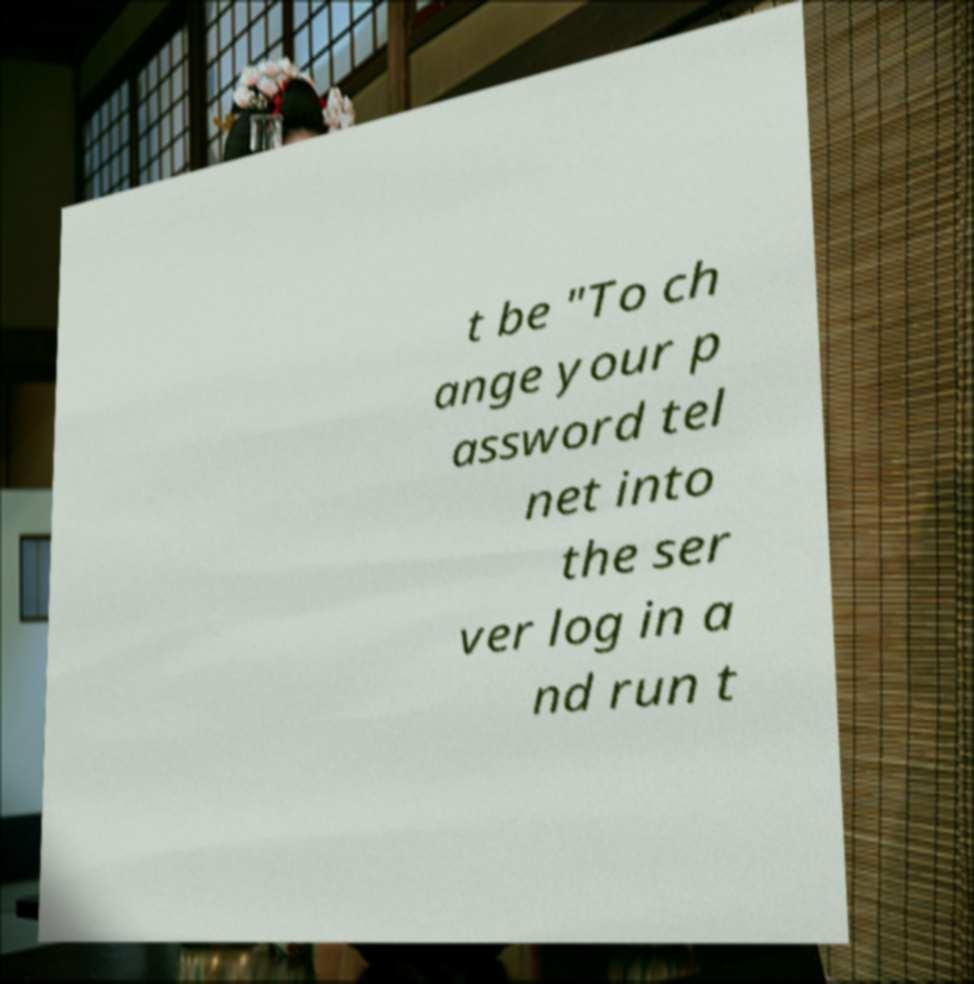Can you accurately transcribe the text from the provided image for me? t be "To ch ange your p assword tel net into the ser ver log in a nd run t 